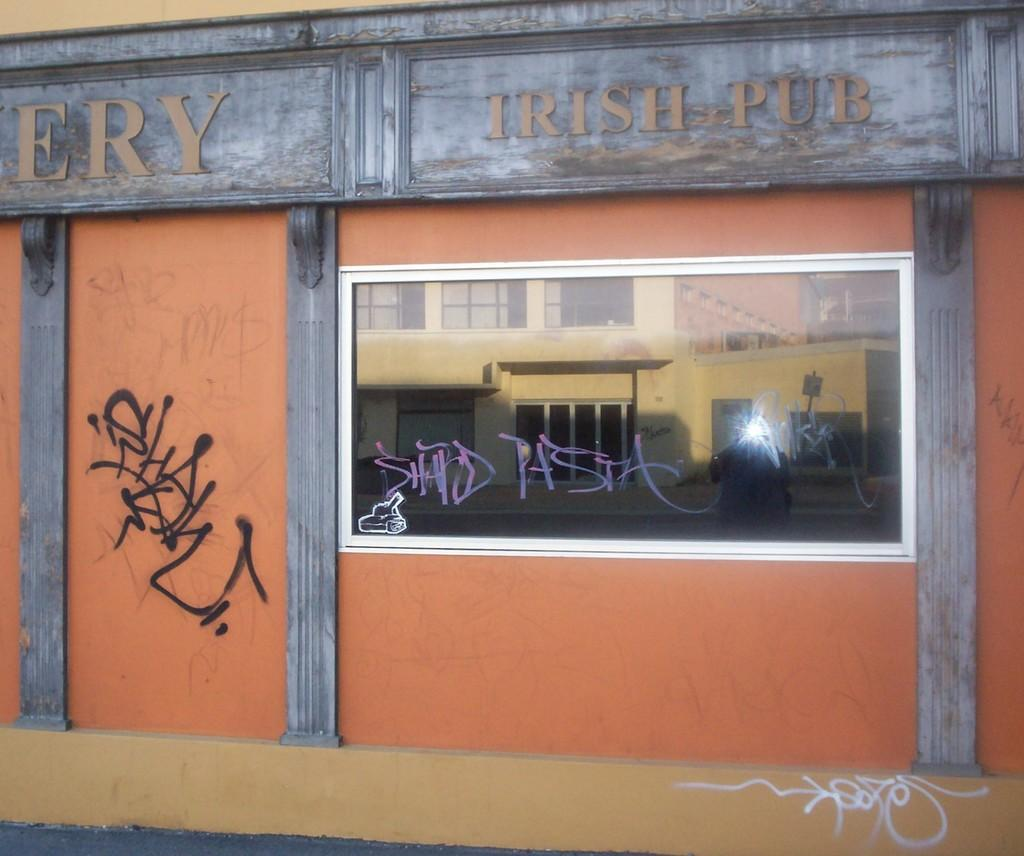What is the main subject of the image? The main subject of the image is a wall of a building. What can be seen on the wall? There is some art on the wall and a name on the wall. What type of window is present on the wall? There is a glass window on the wall. What is visible in the reflection on the glass window? The reflection of a building is visible on the glass window. What type of poison is mentioned in the name on the wall? There is no mention of poison in the name on the wall; it is simply a name. How does the son feel about the art on the wall? There is no information about a son or their feelings in the image or the provided facts. 